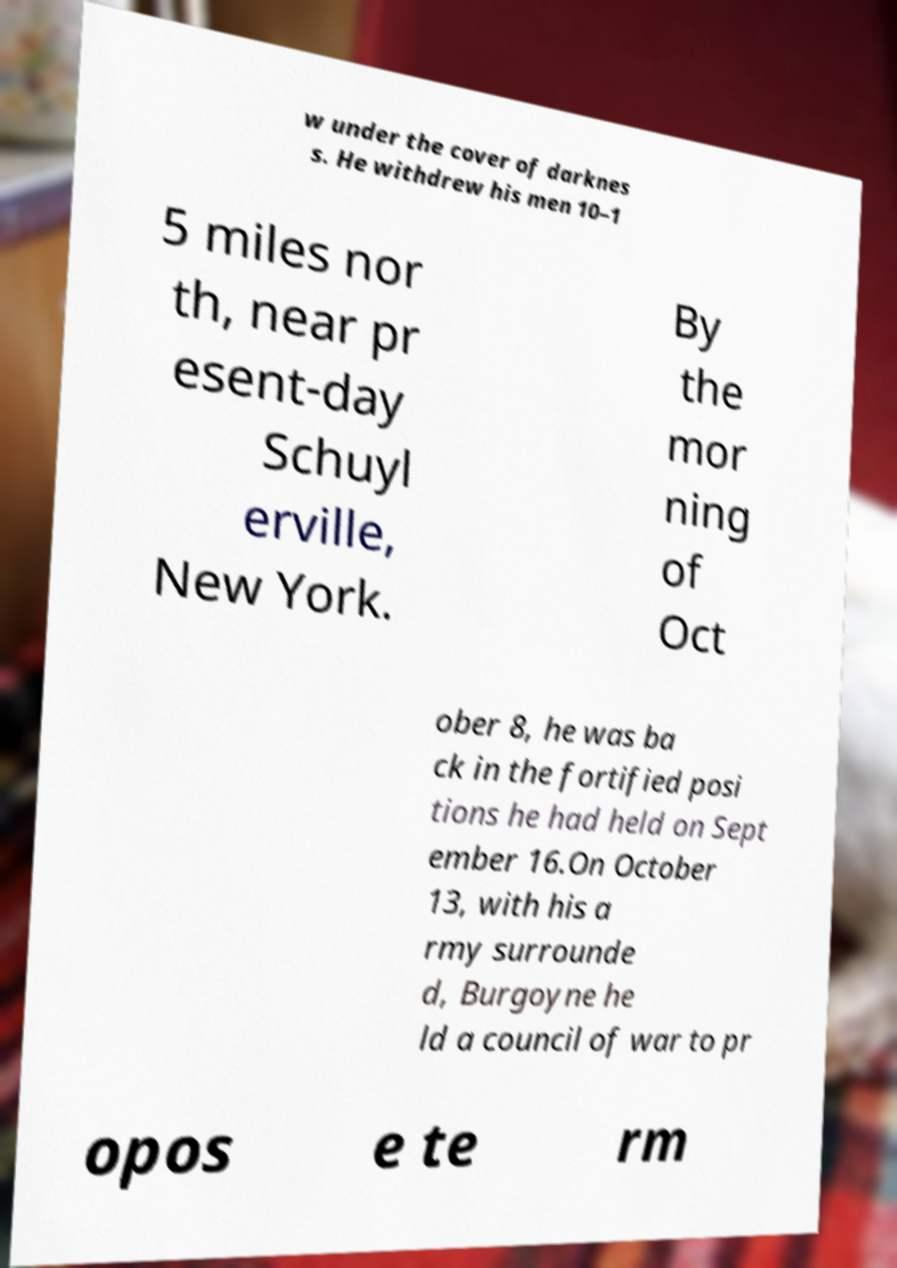Can you accurately transcribe the text from the provided image for me? w under the cover of darknes s. He withdrew his men 10–1 5 miles nor th, near pr esent-day Schuyl erville, New York. By the mor ning of Oct ober 8, he was ba ck in the fortified posi tions he had held on Sept ember 16.On October 13, with his a rmy surrounde d, Burgoyne he ld a council of war to pr opos e te rm 